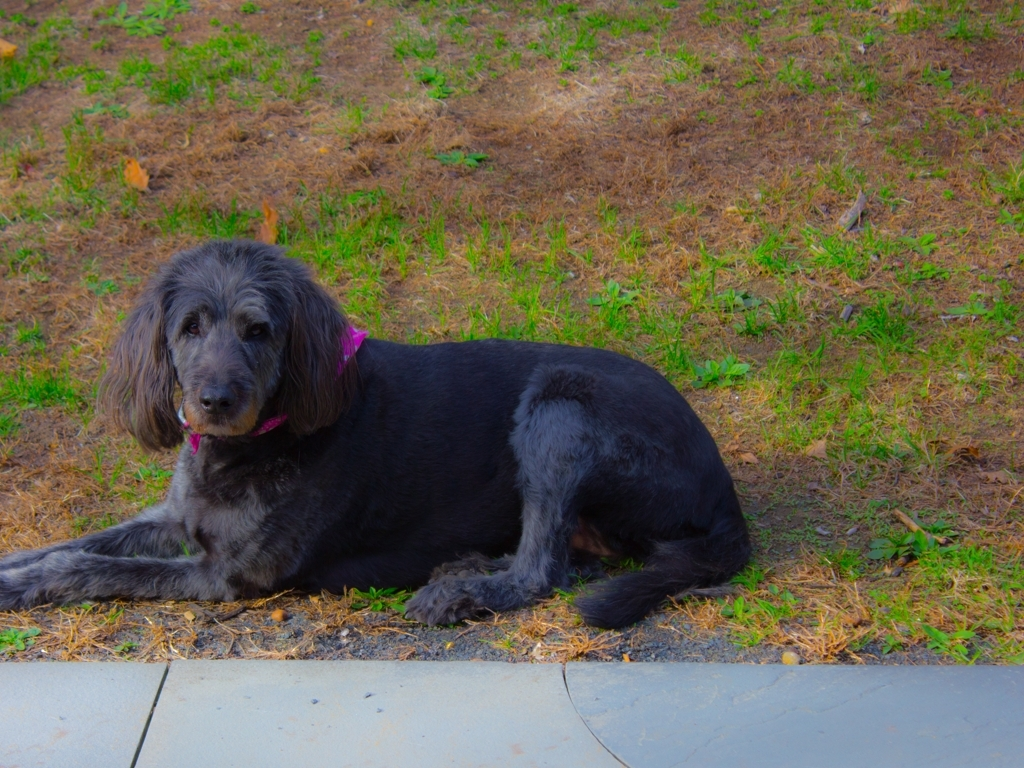How does the dog's body language suggest it is feeling? From its relaxed posture, with its front paws extended and a calm, alert expression, the dog seems to be quite comfortable and at ease in its environment. 